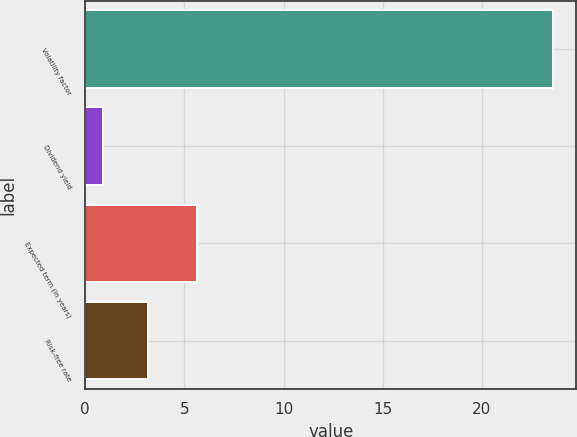Convert chart. <chart><loc_0><loc_0><loc_500><loc_500><bar_chart><fcel>Volatility factor<fcel>Dividend yield<fcel>Expected term (in years)<fcel>Risk-free rate<nl><fcel>23.6<fcel>0.9<fcel>5.66<fcel>3.17<nl></chart> 